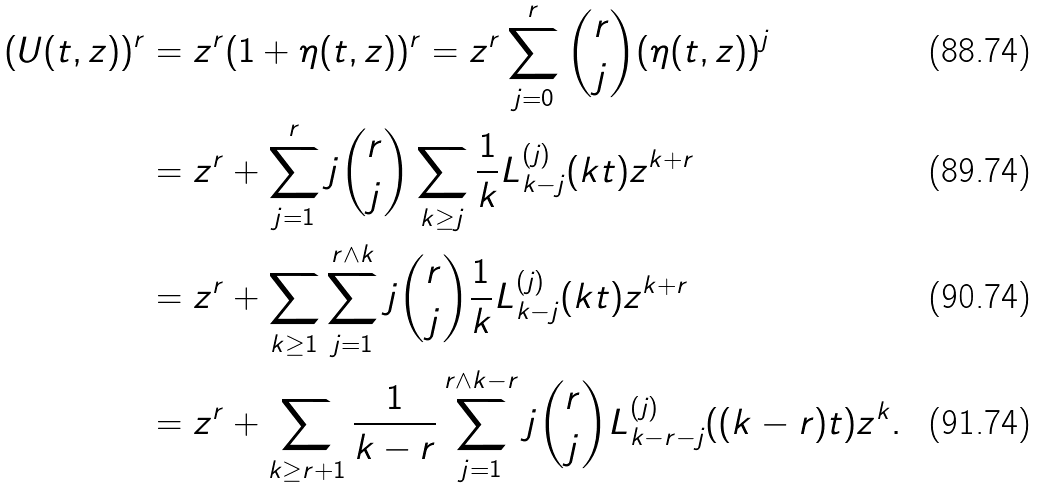Convert formula to latex. <formula><loc_0><loc_0><loc_500><loc_500>( U ( t , z ) ) ^ { r } & = z ^ { r } ( 1 + \eta ( t , z ) ) ^ { r } = z ^ { r } \sum _ { j = 0 } ^ { r } \binom { r } { j } ( \eta ( t , z ) ) ^ { j } \\ & = z ^ { r } + \sum _ { j = 1 } ^ { r } j \binom { r } { j } \sum _ { k \geq j } \frac { 1 } { k } L ^ { ( j ) } _ { k - j } ( k t ) z ^ { k + r } \\ & = z ^ { r } + \sum _ { k \geq 1 } \sum _ { j = 1 } ^ { r \wedge k } j \binom { r } { j } \frac { 1 } { k } L ^ { ( j ) } _ { k - j } ( k t ) z ^ { k + r } \\ & = z ^ { r } + \sum _ { k \geq r + 1 } \frac { 1 } { k - r } \sum _ { j = 1 } ^ { r \wedge k - r } j \binom { r } { j } L ^ { ( j ) } _ { k - r - j } ( ( k - r ) t ) z ^ { k } .</formula> 